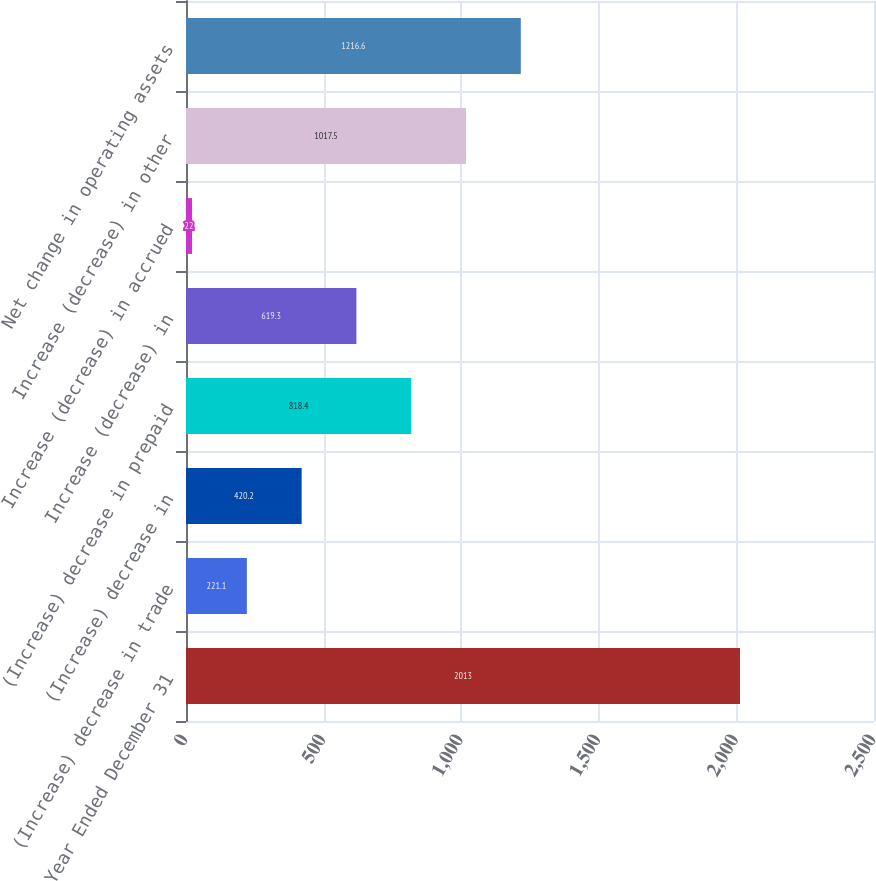<chart> <loc_0><loc_0><loc_500><loc_500><bar_chart><fcel>Year Ended December 31<fcel>(Increase) decrease in trade<fcel>(Increase) decrease in<fcel>(Increase) decrease in prepaid<fcel>Increase (decrease) in<fcel>Increase (decrease) in accrued<fcel>Increase (decrease) in other<fcel>Net change in operating assets<nl><fcel>2013<fcel>221.1<fcel>420.2<fcel>818.4<fcel>619.3<fcel>22<fcel>1017.5<fcel>1216.6<nl></chart> 